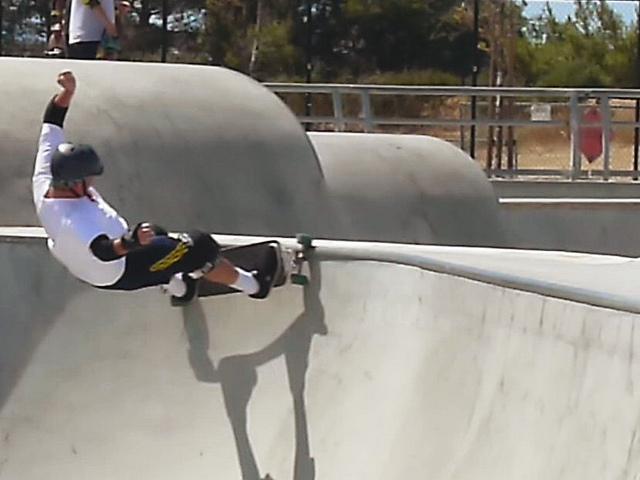How many people can be seen?
Give a very brief answer. 2. 